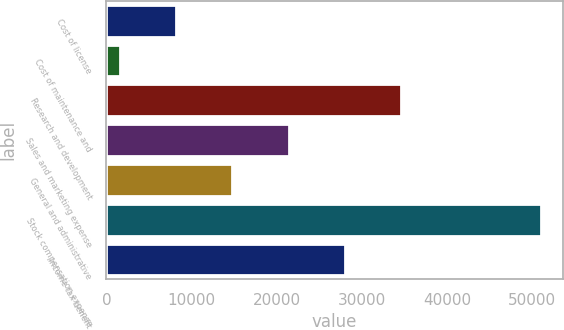<chart> <loc_0><loc_0><loc_500><loc_500><bar_chart><fcel>Cost of license<fcel>Cost of maintenance and<fcel>Research and development<fcel>Sales and marketing expense<fcel>General and administrative<fcel>Stock compensation expense<fcel>Income tax benefit<nl><fcel>8216.3<fcel>1628<fcel>34569.5<fcel>21392.9<fcel>14804.6<fcel>51065<fcel>27981.2<nl></chart> 